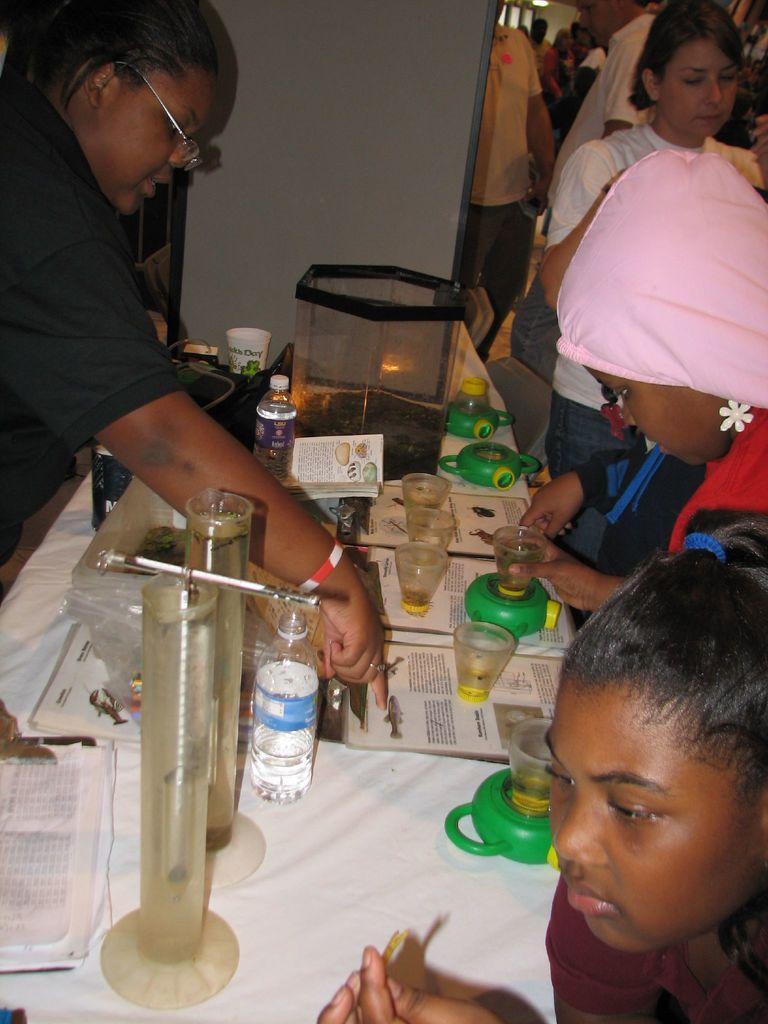Can you describe this image briefly? In the center we can see table,on table there is a water bottle,papers,glasses,book and pen. Round table we can see few persons were standing. In the background there is a wall and group of persons were standing. 